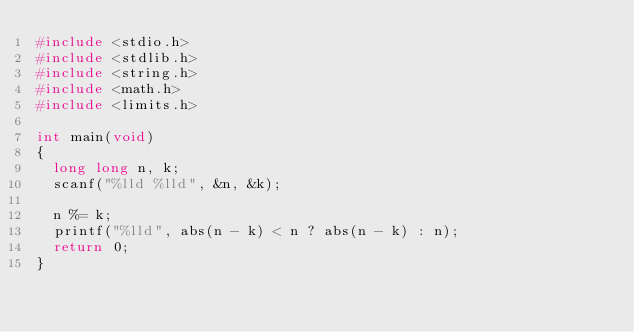Convert code to text. <code><loc_0><loc_0><loc_500><loc_500><_C_>#include <stdio.h>
#include <stdlib.h>
#include <string.h>
#include <math.h>
#include <limits.h>

int main(void)
{
	long long n, k;
	scanf("%lld %lld", &n, &k);

	n %= k;
	printf("%lld", abs(n - k) < n ? abs(n - k) : n);
	return 0;
}
</code> 